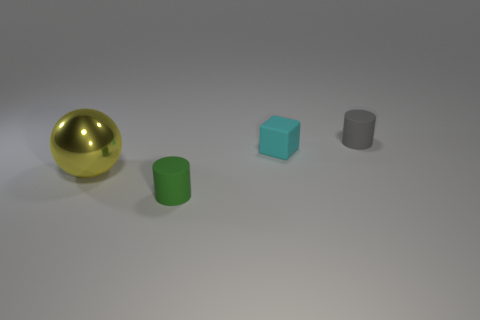Subtract all green cylinders. How many cylinders are left? 1 Subtract all cubes. How many objects are left? 3 Subtract 1 spheres. How many spheres are left? 0 Add 2 big balls. How many big balls exist? 3 Add 3 big red shiny cubes. How many objects exist? 7 Subtract 0 blue cylinders. How many objects are left? 4 Subtract all gray cylinders. Subtract all green balls. How many cylinders are left? 1 Subtract all purple cylinders. How many blue spheres are left? 0 Subtract all gray rubber things. Subtract all tiny gray matte objects. How many objects are left? 2 Add 3 yellow spheres. How many yellow spheres are left? 4 